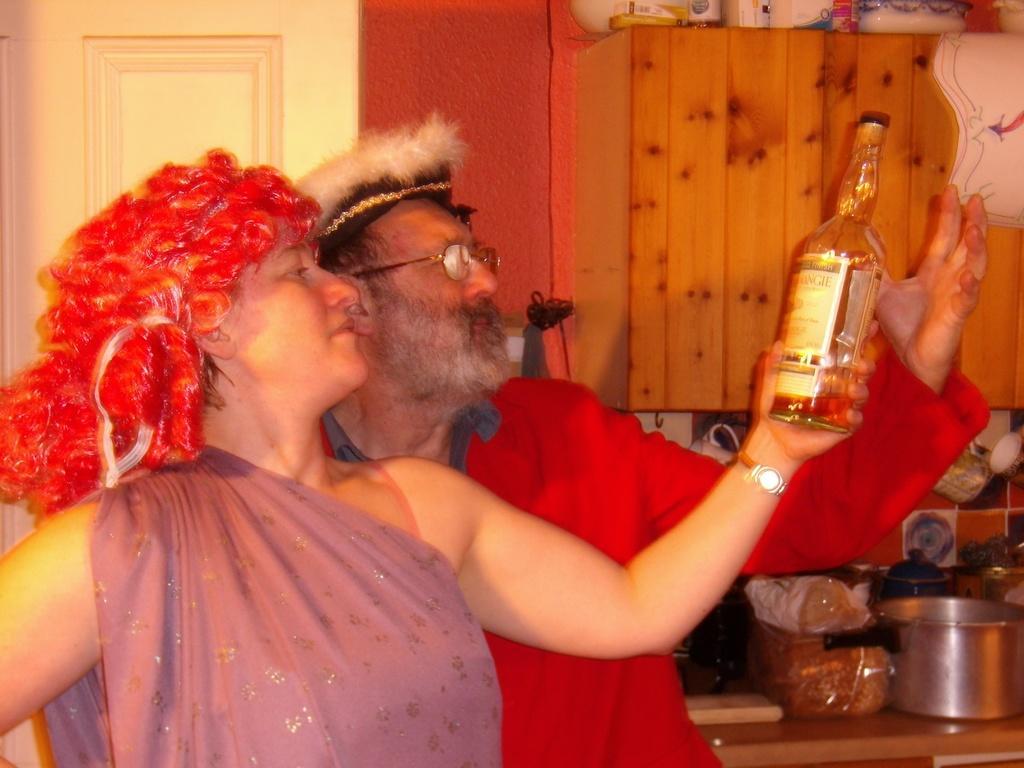Please provide a concise description of this image. In this picture we can see a woman and a man holding bottle and giving a still. On the table we can see a pressure cooker, packet of food, cups. On the background we can see curtain and a door. 